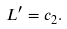<formula> <loc_0><loc_0><loc_500><loc_500>L ^ { \prime } = c _ { 2 } .</formula> 